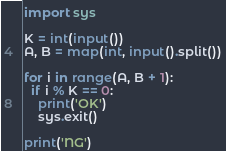Convert code to text. <code><loc_0><loc_0><loc_500><loc_500><_Python_>import sys

K = int(input())
A, B = map(int, input().split())

for i in range(A, B + 1):
  if i % K == 0:
    print('OK')
    sys.exit()
	
print('NG')
</code> 